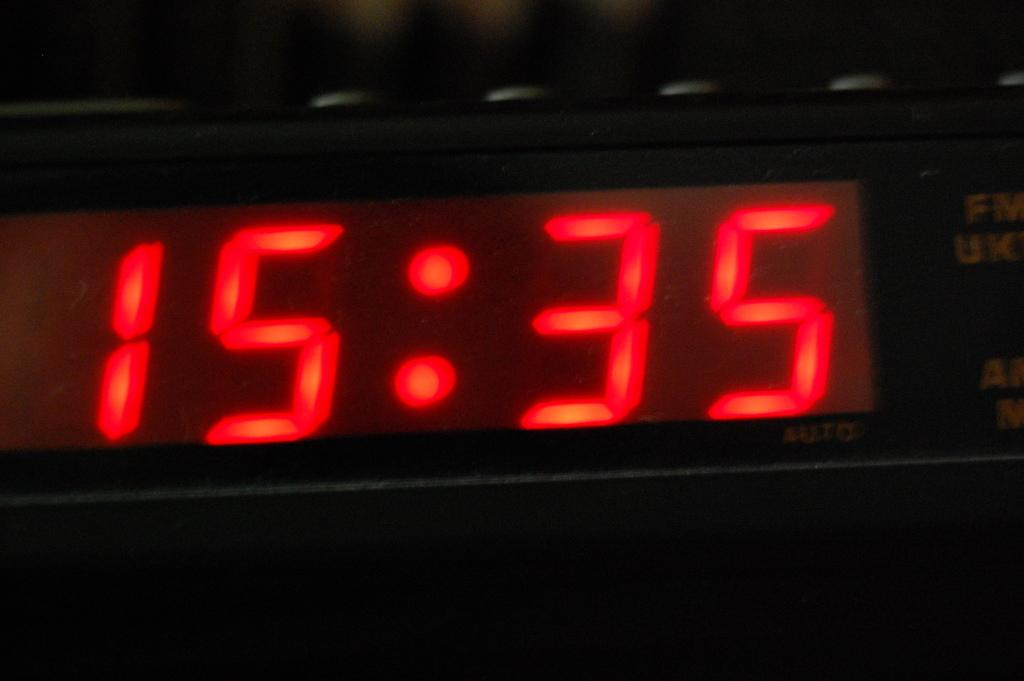<image>
Describe the image concisely. An led clock display that shows the numbers 15:35 